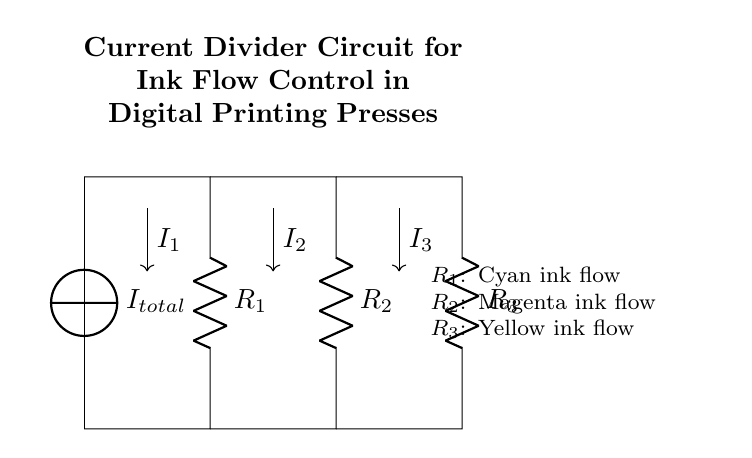What type of circuit is represented in the diagram? The diagram represents a parallel resistor network, which allows current to divide among the different branches. Since all resistors are connected in parallel, they share the same voltage across them.
Answer: Parallel What are the components labeled in the circuit? The circuit includes three resistors labeled as R1, R2, and R3, representing the flow of different colored ink. Each resistor corresponds to a specific color: cyan, magenta, and yellow.
Answer: R1, R2, R3 Which ink flow is represented by R2? R2 corresponds to the magenta ink flow as indicated in the annotations next to the circuit. This resistor is part of the parallel configuration utilized for controlling ink distribution.
Answer: Magenta How is the total current divided among the resistors? In a current divider, the total current entering the circuit is split among the resistors based on their resistances. Lower resistance leads to higher current through that branch, in accordance with Ohm's law.
Answer: Based on resistance What is the current flowing through R1 if the total current is 10 milliamps? To find the current through R1, use the current divider rule: I1 = (R_total/R1) * I_total. The current through R1 depends on its resistance compared to the total resistance of the parallel network. If R1 is the least resistive, it will have more current.
Answer: Current through R1 (depends on R values) What happens to the total current if R3 is removed from the circuit? If R3 is removed, the total current would increase through the remaining resistors (R1 and R2) since the overall resistance decreases. The remaining resistors will draw more current due to the decrease in the circuit's resistance.
Answer: Total current increases 